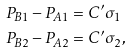Convert formula to latex. <formula><loc_0><loc_0><loc_500><loc_500>P _ { B 1 } - P _ { A 1 } & = C ^ { \prime } \sigma _ { 1 } \\ P _ { B 2 } - P _ { A 2 } & = C ^ { \prime } \sigma _ { 2 } ,</formula> 